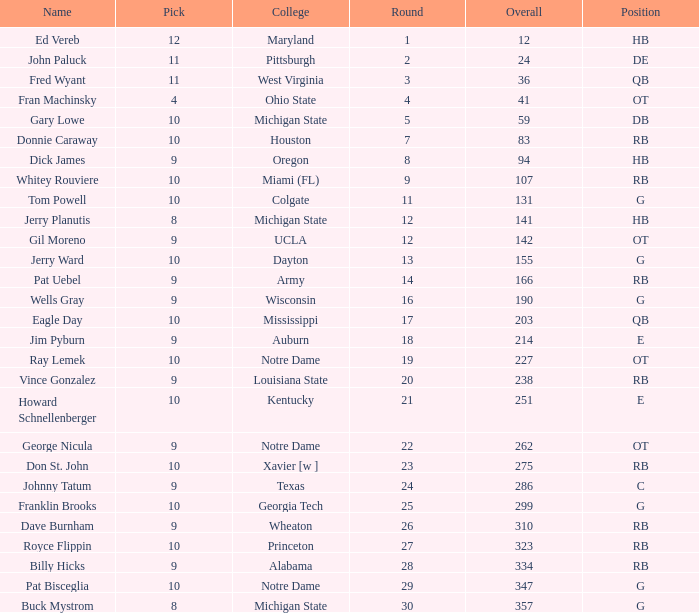What is the highest round number for donnie caraway? 7.0. 